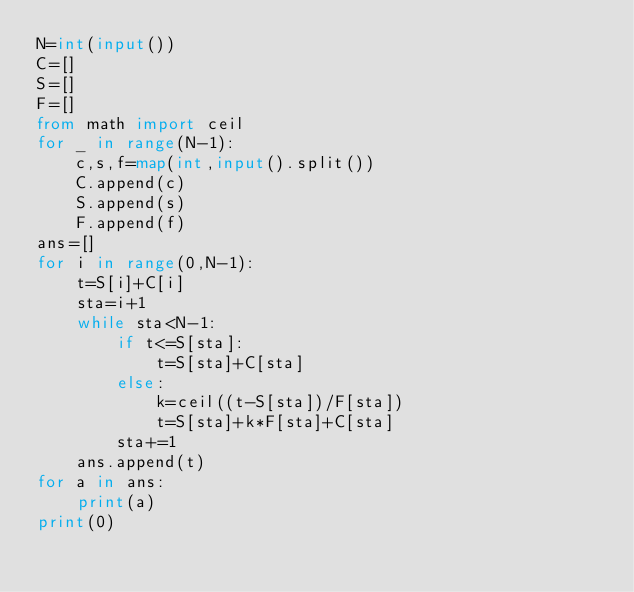<code> <loc_0><loc_0><loc_500><loc_500><_Python_>N=int(input())
C=[]
S=[]
F=[]
from math import ceil
for _ in range(N-1):
    c,s,f=map(int,input().split())
    C.append(c)
    S.append(s)
    F.append(f)
ans=[]
for i in range(0,N-1):
    t=S[i]+C[i]
    sta=i+1
    while sta<N-1:
        if t<=S[sta]:
            t=S[sta]+C[sta]
        else:
            k=ceil((t-S[sta])/F[sta])
            t=S[sta]+k*F[sta]+C[sta]
        sta+=1
    ans.append(t)
for a in ans:
    print(a)
print(0)
</code> 